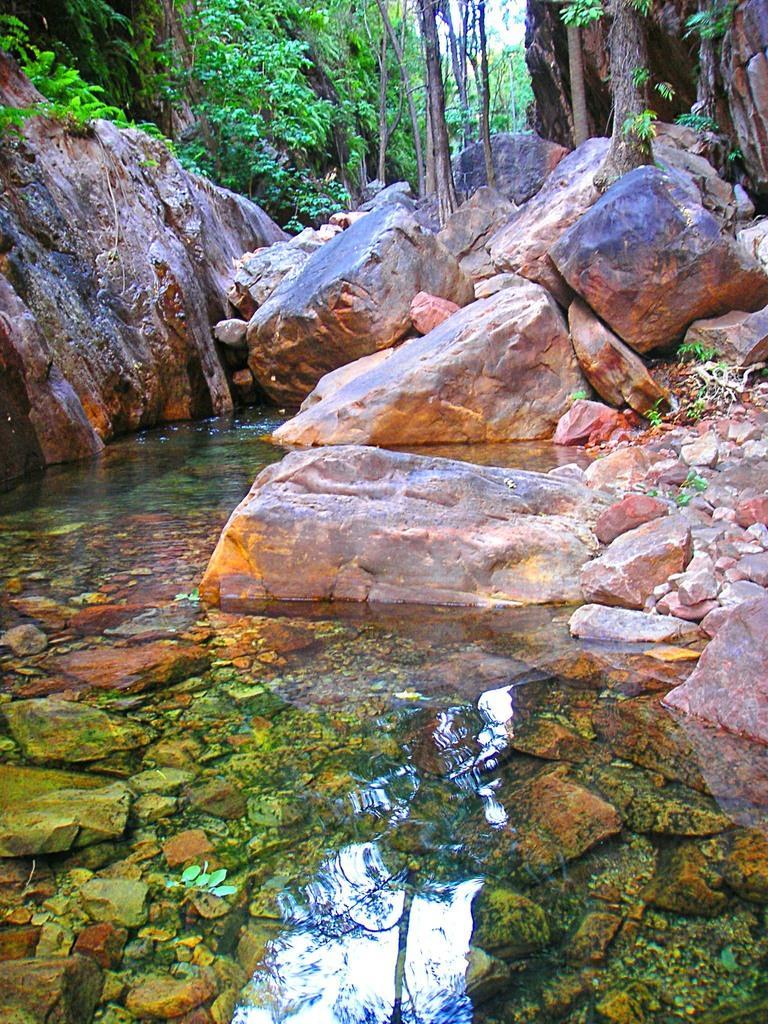Describe this image in one or two sentences. In this image we can see a water body. In the middle of the image, we can see big rocks. At the top of the image, we can see the trees. 